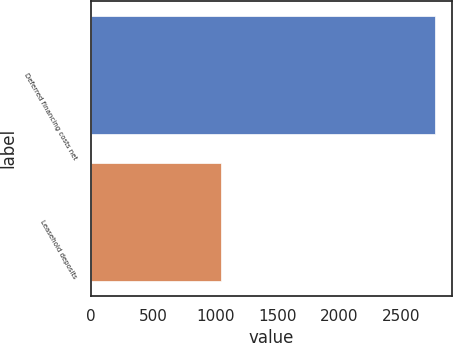<chart> <loc_0><loc_0><loc_500><loc_500><bar_chart><fcel>Deferred financing costs net<fcel>Leasehold deposits<nl><fcel>2768<fcel>1043<nl></chart> 